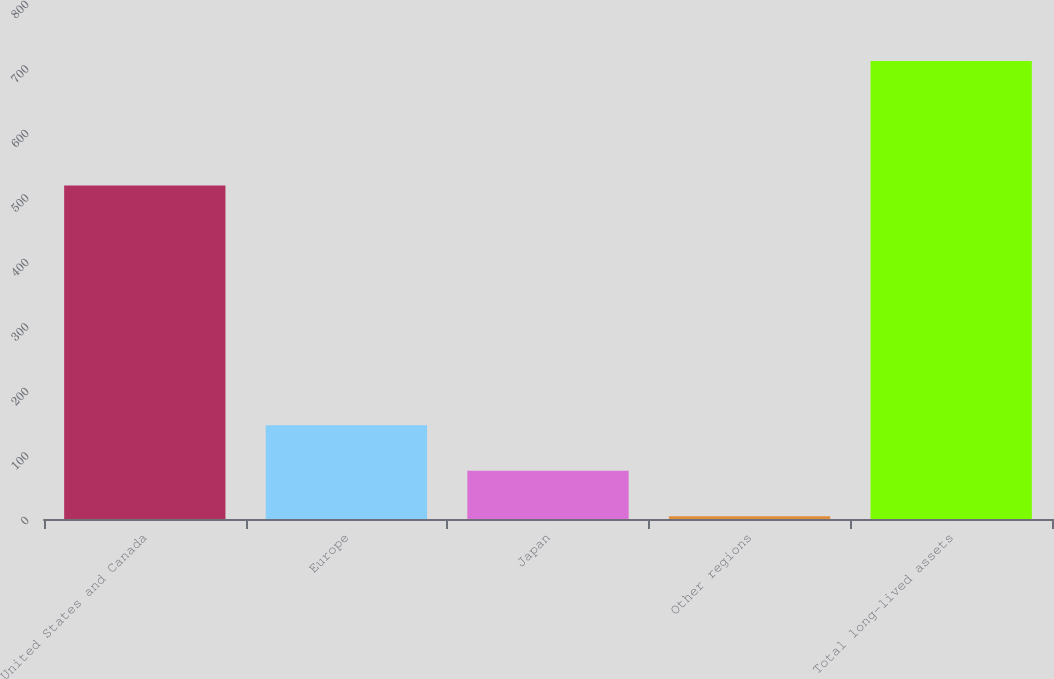Convert chart. <chart><loc_0><loc_0><loc_500><loc_500><bar_chart><fcel>United States and Canada<fcel>Europe<fcel>Japan<fcel>Other regions<fcel>Total long-lived assets<nl><fcel>517.1<fcel>145.5<fcel>74.95<fcel>4.4<fcel>709.9<nl></chart> 